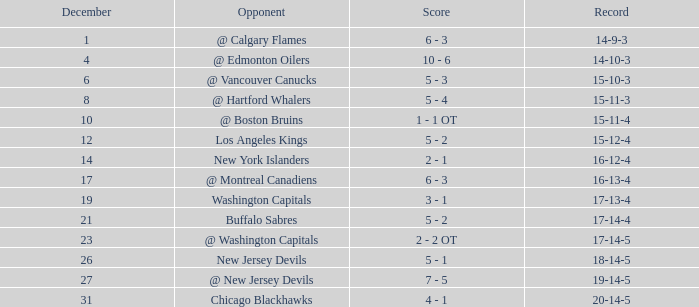Game larger than 34, and a December smaller than 23 had what record? 17-14-4. 